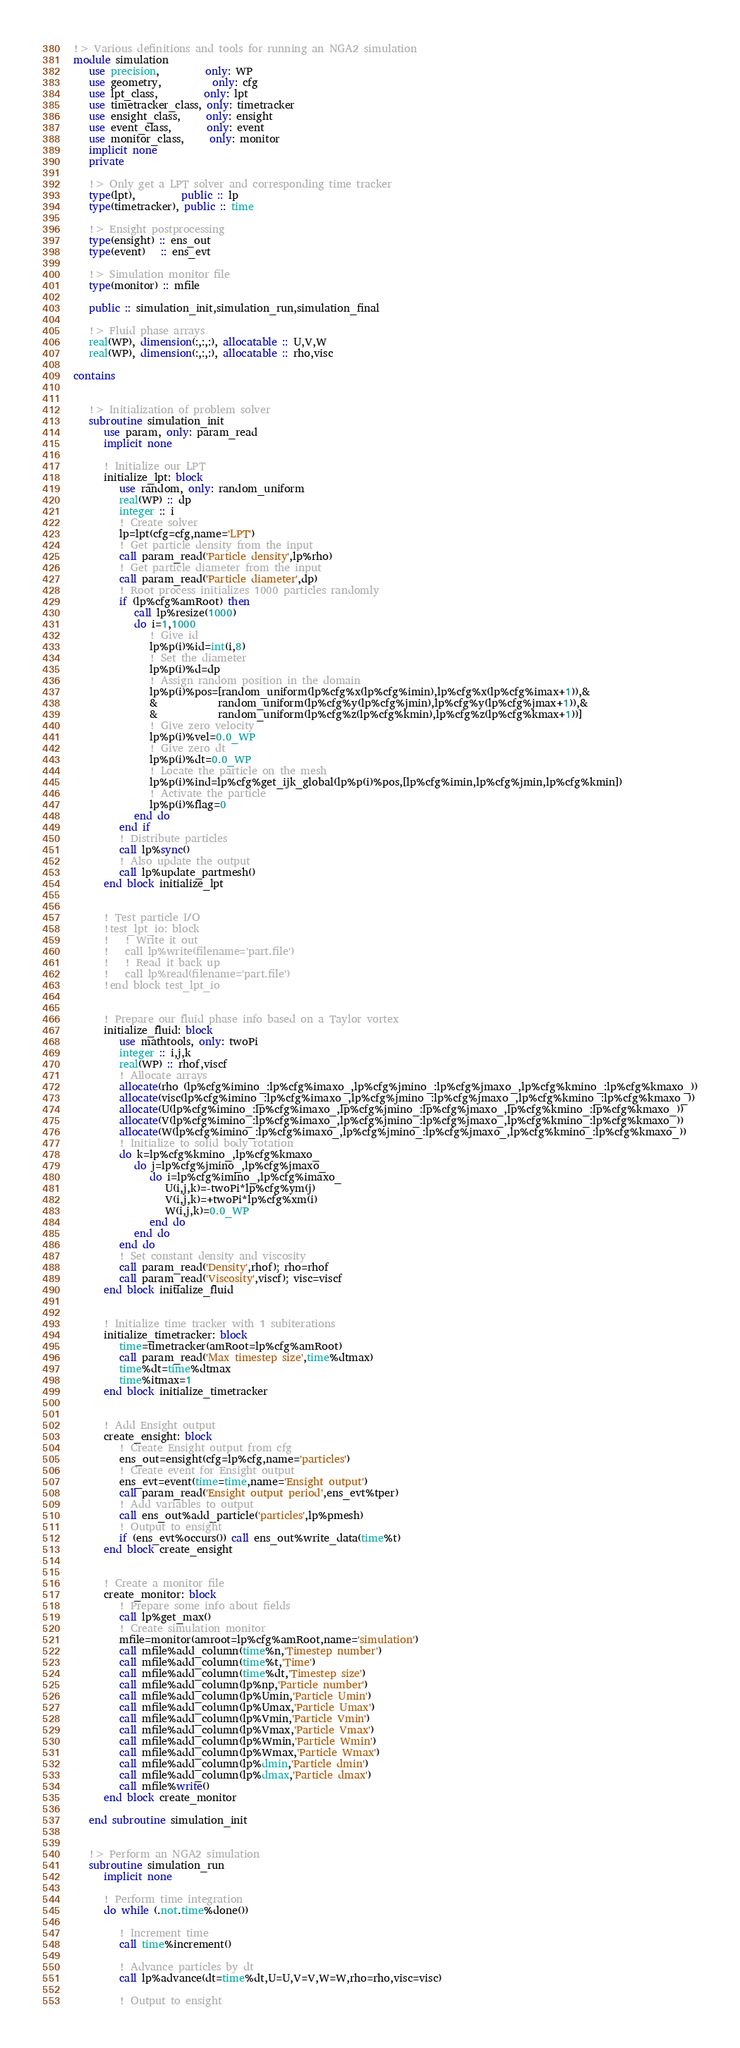Convert code to text. <code><loc_0><loc_0><loc_500><loc_500><_FORTRAN_>!> Various definitions and tools for running an NGA2 simulation
module simulation
   use precision,         only: WP
   use geometry,          only: cfg
   use lpt_class,         only: lpt
   use timetracker_class, only: timetracker
   use ensight_class,     only: ensight
   use event_class,       only: event
   use monitor_class,     only: monitor
   implicit none
   private
   
   !> Only get a LPT solver and corresponding time tracker
   type(lpt),         public :: lp
   type(timetracker), public :: time
   
   !> Ensight postprocessing
   type(ensight) :: ens_out
   type(event)   :: ens_evt
   
   !> Simulation monitor file
   type(monitor) :: mfile
   
   public :: simulation_init,simulation_run,simulation_final
   
   !> Fluid phase arrays
   real(WP), dimension(:,:,:), allocatable :: U,V,W
   real(WP), dimension(:,:,:), allocatable :: rho,visc
   
contains
   
   
   !> Initialization of problem solver
   subroutine simulation_init
      use param, only: param_read
      implicit none
      
      ! Initialize our LPT
      initialize_lpt: block
         use random, only: random_uniform
         real(WP) :: dp
         integer :: i
         ! Create solver
         lp=lpt(cfg=cfg,name='LPT')
         ! Get particle density from the input
         call param_read('Particle density',lp%rho)
         ! Get particle diameter from the input
         call param_read('Particle diameter',dp)
         ! Root process initializes 1000 particles randomly
         if (lp%cfg%amRoot) then
            call lp%resize(1000)
            do i=1,1000
               ! Give id
               lp%p(i)%id=int(i,8)
               ! Set the diameter
               lp%p(i)%d=dp
               ! Assign random position in the domain
               lp%p(i)%pos=[random_uniform(lp%cfg%x(lp%cfg%imin),lp%cfg%x(lp%cfg%imax+1)),&
               &            random_uniform(lp%cfg%y(lp%cfg%jmin),lp%cfg%y(lp%cfg%jmax+1)),&
               &            random_uniform(lp%cfg%z(lp%cfg%kmin),lp%cfg%z(lp%cfg%kmax+1))]
               ! Give zero velocity
               lp%p(i)%vel=0.0_WP
               ! Give zero dt
               lp%p(i)%dt=0.0_WP
               ! Locate the particle on the mesh
               lp%p(i)%ind=lp%cfg%get_ijk_global(lp%p(i)%pos,[lp%cfg%imin,lp%cfg%jmin,lp%cfg%kmin])
               ! Activate the particle
               lp%p(i)%flag=0
            end do
         end if
         ! Distribute particles
         call lp%sync()
         ! Also update the output
         call lp%update_partmesh()
      end block initialize_lpt
      
      
      ! Test particle I/O
      !test_lpt_io: block
      !   ! Write it out
      !   call lp%write(filename='part.file')
      !   ! Read it back up
      !   call lp%read(filename='part.file')
      !end block test_lpt_io
      
      
      ! Prepare our fluid phase info based on a Taylor vortex
      initialize_fluid: block
         use mathtools, only: twoPi
         integer :: i,j,k
         real(WP) :: rhof,viscf
         ! Allocate arrays
         allocate(rho (lp%cfg%imino_:lp%cfg%imaxo_,lp%cfg%jmino_:lp%cfg%jmaxo_,lp%cfg%kmino_:lp%cfg%kmaxo_))
         allocate(visc(lp%cfg%imino_:lp%cfg%imaxo_,lp%cfg%jmino_:lp%cfg%jmaxo_,lp%cfg%kmino_:lp%cfg%kmaxo_))
         allocate(U(lp%cfg%imino_:lp%cfg%imaxo_,lp%cfg%jmino_:lp%cfg%jmaxo_,lp%cfg%kmino_:lp%cfg%kmaxo_))
         allocate(V(lp%cfg%imino_:lp%cfg%imaxo_,lp%cfg%jmino_:lp%cfg%jmaxo_,lp%cfg%kmino_:lp%cfg%kmaxo_))
         allocate(W(lp%cfg%imino_:lp%cfg%imaxo_,lp%cfg%jmino_:lp%cfg%jmaxo_,lp%cfg%kmino_:lp%cfg%kmaxo_))
         ! Initialize to solid body rotation
         do k=lp%cfg%kmino_,lp%cfg%kmaxo_
            do j=lp%cfg%jmino_,lp%cfg%jmaxo_
               do i=lp%cfg%imino_,lp%cfg%imaxo_
                  U(i,j,k)=-twoPi*lp%cfg%ym(j)
                  V(i,j,k)=+twoPi*lp%cfg%xm(i)
                  W(i,j,k)=0.0_WP
               end do
            end do
         end do
         ! Set constant density and viscosity
         call param_read('Density',rhof); rho=rhof
         call param_read('Viscosity',viscf); visc=viscf
      end block initialize_fluid
      
      
      ! Initialize time tracker with 1 subiterations
      initialize_timetracker: block
         time=timetracker(amRoot=lp%cfg%amRoot)
         call param_read('Max timestep size',time%dtmax)
         time%dt=time%dtmax
         time%itmax=1
      end block initialize_timetracker
      
      
      ! Add Ensight output
      create_ensight: block
         ! Create Ensight output from cfg
         ens_out=ensight(cfg=lp%cfg,name='particles')
         ! Create event for Ensight output
         ens_evt=event(time=time,name='Ensight output')
         call param_read('Ensight output period',ens_evt%tper)
         ! Add variables to output
         call ens_out%add_particle('particles',lp%pmesh)
         ! Output to ensight
         if (ens_evt%occurs()) call ens_out%write_data(time%t)
      end block create_ensight
      
      
      ! Create a monitor file
      create_monitor: block
         ! Prepare some info about fields
         call lp%get_max()
         ! Create simulation monitor
         mfile=monitor(amroot=lp%cfg%amRoot,name='simulation')
         call mfile%add_column(time%n,'Timestep number')
         call mfile%add_column(time%t,'Time')
         call mfile%add_column(time%dt,'Timestep size')
         call mfile%add_column(lp%np,'Particle number')
         call mfile%add_column(lp%Umin,'Particle Umin')
         call mfile%add_column(lp%Umax,'Particle Umax')
         call mfile%add_column(lp%Vmin,'Particle Vmin')
         call mfile%add_column(lp%Vmax,'Particle Vmax')
         call mfile%add_column(lp%Wmin,'Particle Wmin')
         call mfile%add_column(lp%Wmax,'Particle Wmax')
         call mfile%add_column(lp%dmin,'Particle dmin')
         call mfile%add_column(lp%dmax,'Particle dmax')
         call mfile%write()
      end block create_monitor
      
   end subroutine simulation_init
   
   
   !> Perform an NGA2 simulation
   subroutine simulation_run
      implicit none
      
      ! Perform time integration
      do while (.not.time%done())
         
         ! Increment time
         call time%increment()
         
         ! Advance particles by dt
         call lp%advance(dt=time%dt,U=U,V=V,W=W,rho=rho,visc=visc)
         
         ! Output to ensight</code> 